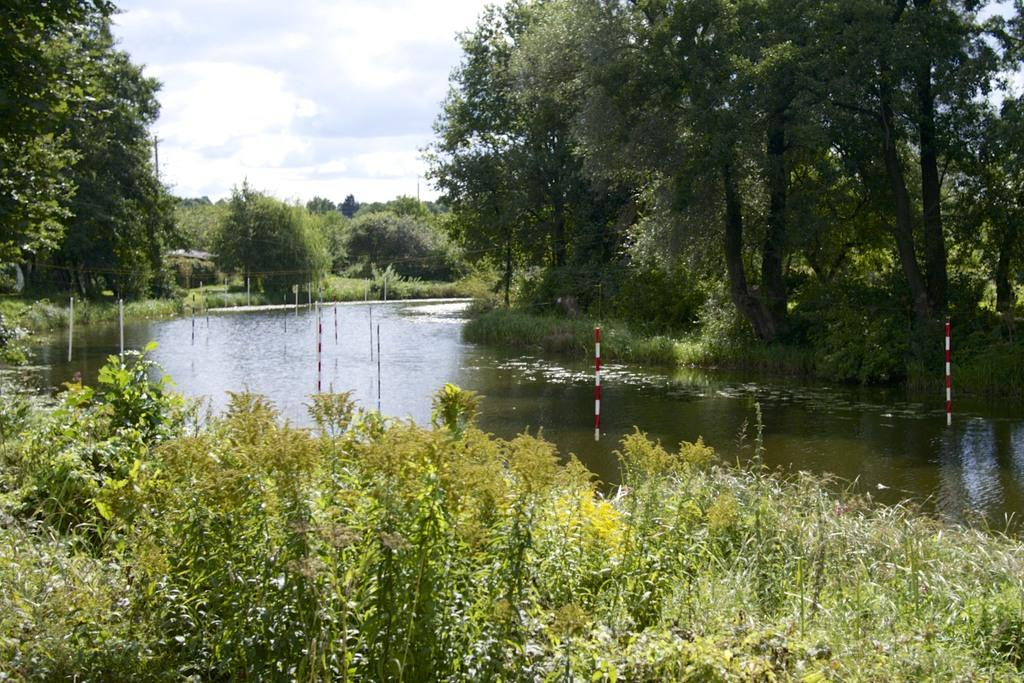What type of vegetation can be seen in the image? There are plants and trees in the image. What natural element is visible in the image? Water is visible in the image. What part of the natural environment is visible in the image? The sky is visible in the image. What type of kitty can be seen playing with a brick in the image? There is no kitty or brick present in the image. 